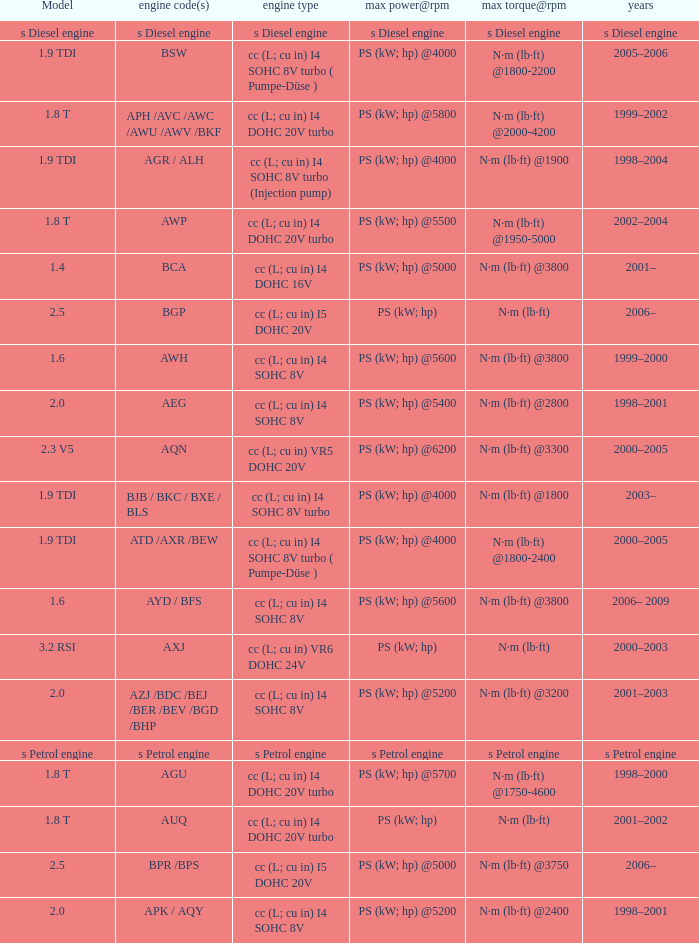Which engine type was used in the model 2.3 v5? Cc (l; cu in) vr5 dohc 20v. 